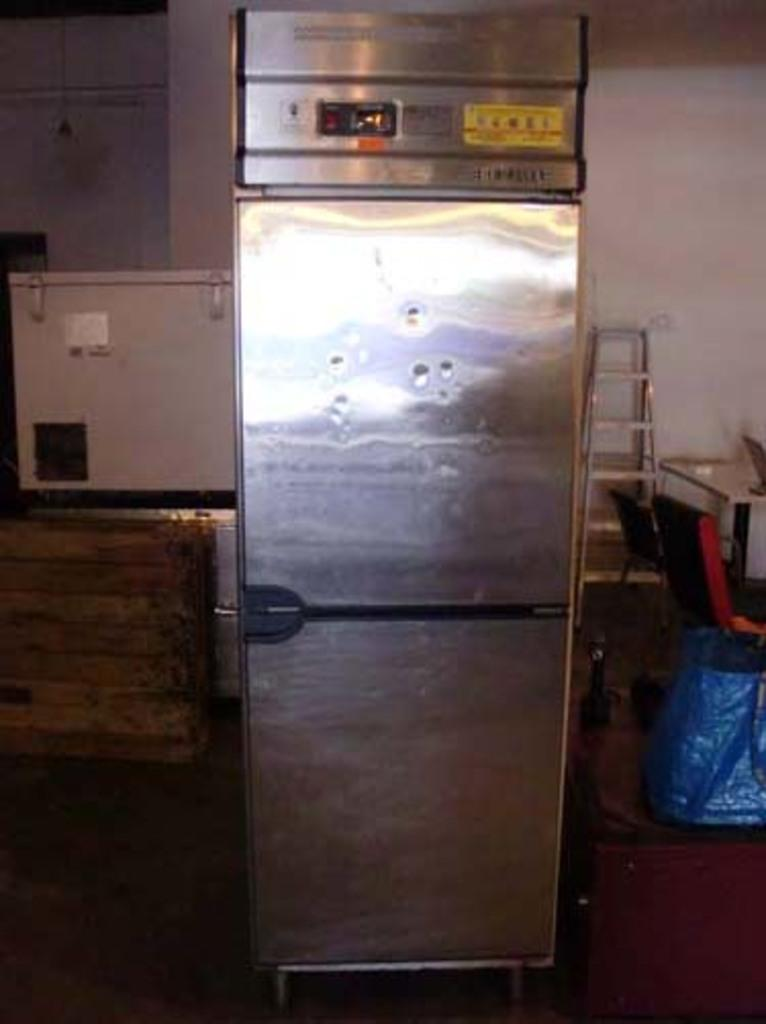<image>
Offer a succinct explanation of the picture presented. A silver fridge with a bunch of dents on it with a yellow sign with the number 4 on it. 